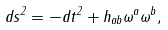Convert formula to latex. <formula><loc_0><loc_0><loc_500><loc_500>d s ^ { 2 } = - d t ^ { 2 } + h _ { a b } \omega ^ { a } \omega ^ { b } ,</formula> 